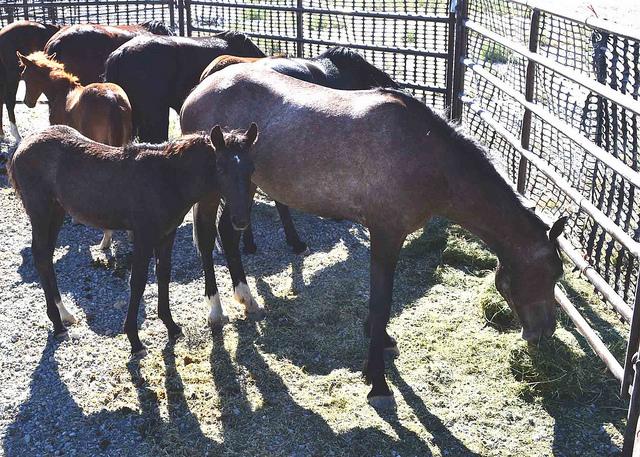Are the horses afraid?
Give a very brief answer. No. What is the horse eating?
Be succinct. Hay. Which ones are juveniles?
Concise answer only. Smaller ones. 